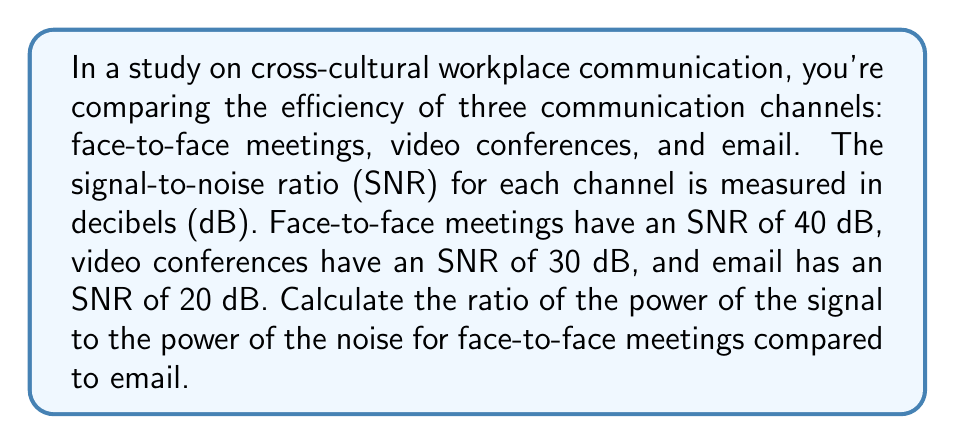Help me with this question. To solve this problem, we'll use the following steps:

1) The formula for SNR in decibels is:
   $$ SNR_{dB} = 10 \log_{10}\left(\frac{P_{signal}}{P_{noise}}\right) $$

2) For face-to-face meetings:
   $$ 40 = 10 \log_{10}\left(\frac{P_{signal,f2f}}{P_{noise,f2f}}\right) $$

3) For email:
   $$ 20 = 10 \log_{10}\left(\frac{P_{signal,email}}{P_{noise,email}}\right) $$

4) To find the ratio of $\frac{P_{signal}}{P_{noise}}$ for each, we need to solve these equations:

   For face-to-face: 
   $$ \frac{40}{10} = \log_{10}\left(\frac{P_{signal,f2f}}{P_{noise,f2f}}\right) $$
   $$ 4 = \log_{10}\left(\frac{P_{signal,f2f}}{P_{noise,f2f}}\right) $$
   $$ 10^4 = \frac{P_{signal,f2f}}{P_{noise,f2f}} = 10000 $$

   For email:
   $$ \frac{20}{10} = \log_{10}\left(\frac{P_{signal,email}}{P_{noise,email}}\right) $$
   $$ 2 = \log_{10}\left(\frac{P_{signal,email}}{P_{noise,email}}\right) $$
   $$ 10^2 = \frac{P_{signal,email}}{P_{noise,email}} = 100 $$

5) The ratio of face-to-face to email is:
   $$ \frac{(P_{signal}/P_{noise})_{f2f}}{(P_{signal}/P_{noise})_{email}} = \frac{10000}{100} = 100 $$

Therefore, the ratio of the power of the signal to the power of the noise for face-to-face meetings is 100 times greater than for email.
Answer: 100 